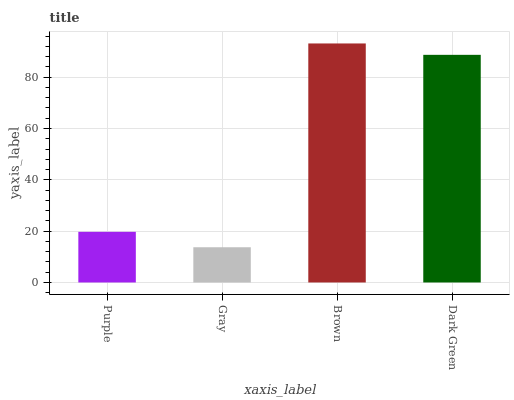Is Gray the minimum?
Answer yes or no. Yes. Is Brown the maximum?
Answer yes or no. Yes. Is Brown the minimum?
Answer yes or no. No. Is Gray the maximum?
Answer yes or no. No. Is Brown greater than Gray?
Answer yes or no. Yes. Is Gray less than Brown?
Answer yes or no. Yes. Is Gray greater than Brown?
Answer yes or no. No. Is Brown less than Gray?
Answer yes or no. No. Is Dark Green the high median?
Answer yes or no. Yes. Is Purple the low median?
Answer yes or no. Yes. Is Brown the high median?
Answer yes or no. No. Is Brown the low median?
Answer yes or no. No. 